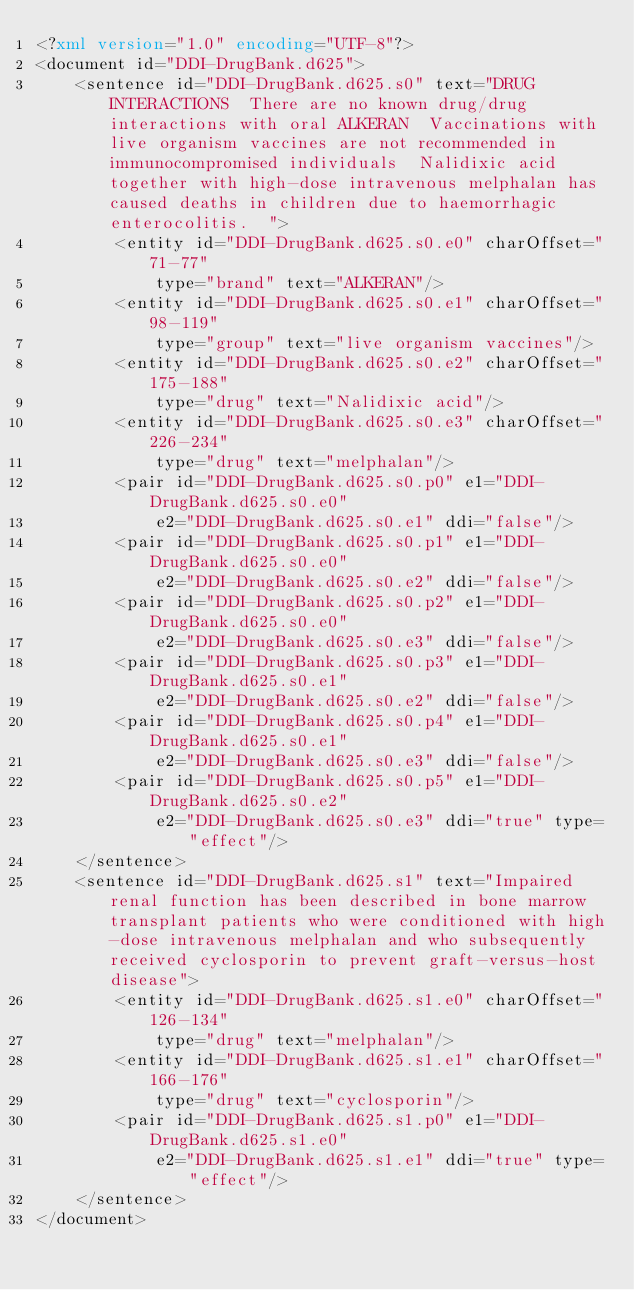Convert code to text. <code><loc_0><loc_0><loc_500><loc_500><_XML_><?xml version="1.0" encoding="UTF-8"?>
<document id="DDI-DrugBank.d625">
    <sentence id="DDI-DrugBank.d625.s0" text="DRUG INTERACTIONS  There are no known drug/drug interactions with oral ALKERAN  Vaccinations with live organism vaccines are not recommended in immunocompromised individuals  Nalidixic acid together with high-dose intravenous melphalan has caused deaths in children due to haemorrhagic enterocolitis.  ">
        <entity id="DDI-DrugBank.d625.s0.e0" charOffset="71-77"
            type="brand" text="ALKERAN"/>
        <entity id="DDI-DrugBank.d625.s0.e1" charOffset="98-119"
            type="group" text="live organism vaccines"/>
        <entity id="DDI-DrugBank.d625.s0.e2" charOffset="175-188"
            type="drug" text="Nalidixic acid"/>
        <entity id="DDI-DrugBank.d625.s0.e3" charOffset="226-234"
            type="drug" text="melphalan"/>
        <pair id="DDI-DrugBank.d625.s0.p0" e1="DDI-DrugBank.d625.s0.e0"
            e2="DDI-DrugBank.d625.s0.e1" ddi="false"/>
        <pair id="DDI-DrugBank.d625.s0.p1" e1="DDI-DrugBank.d625.s0.e0"
            e2="DDI-DrugBank.d625.s0.e2" ddi="false"/>
        <pair id="DDI-DrugBank.d625.s0.p2" e1="DDI-DrugBank.d625.s0.e0"
            e2="DDI-DrugBank.d625.s0.e3" ddi="false"/>
        <pair id="DDI-DrugBank.d625.s0.p3" e1="DDI-DrugBank.d625.s0.e1"
            e2="DDI-DrugBank.d625.s0.e2" ddi="false"/>
        <pair id="DDI-DrugBank.d625.s0.p4" e1="DDI-DrugBank.d625.s0.e1"
            e2="DDI-DrugBank.d625.s0.e3" ddi="false"/>
        <pair id="DDI-DrugBank.d625.s0.p5" e1="DDI-DrugBank.d625.s0.e2"
            e2="DDI-DrugBank.d625.s0.e3" ddi="true" type="effect"/>
    </sentence>
    <sentence id="DDI-DrugBank.d625.s1" text="Impaired renal function has been described in bone marrow transplant patients who were conditioned with high-dose intravenous melphalan and who subsequently received cyclosporin to prevent graft-versus-host disease">
        <entity id="DDI-DrugBank.d625.s1.e0" charOffset="126-134"
            type="drug" text="melphalan"/>
        <entity id="DDI-DrugBank.d625.s1.e1" charOffset="166-176"
            type="drug" text="cyclosporin"/>
        <pair id="DDI-DrugBank.d625.s1.p0" e1="DDI-DrugBank.d625.s1.e0"
            e2="DDI-DrugBank.d625.s1.e1" ddi="true" type="effect"/>
    </sentence>
</document>
</code> 